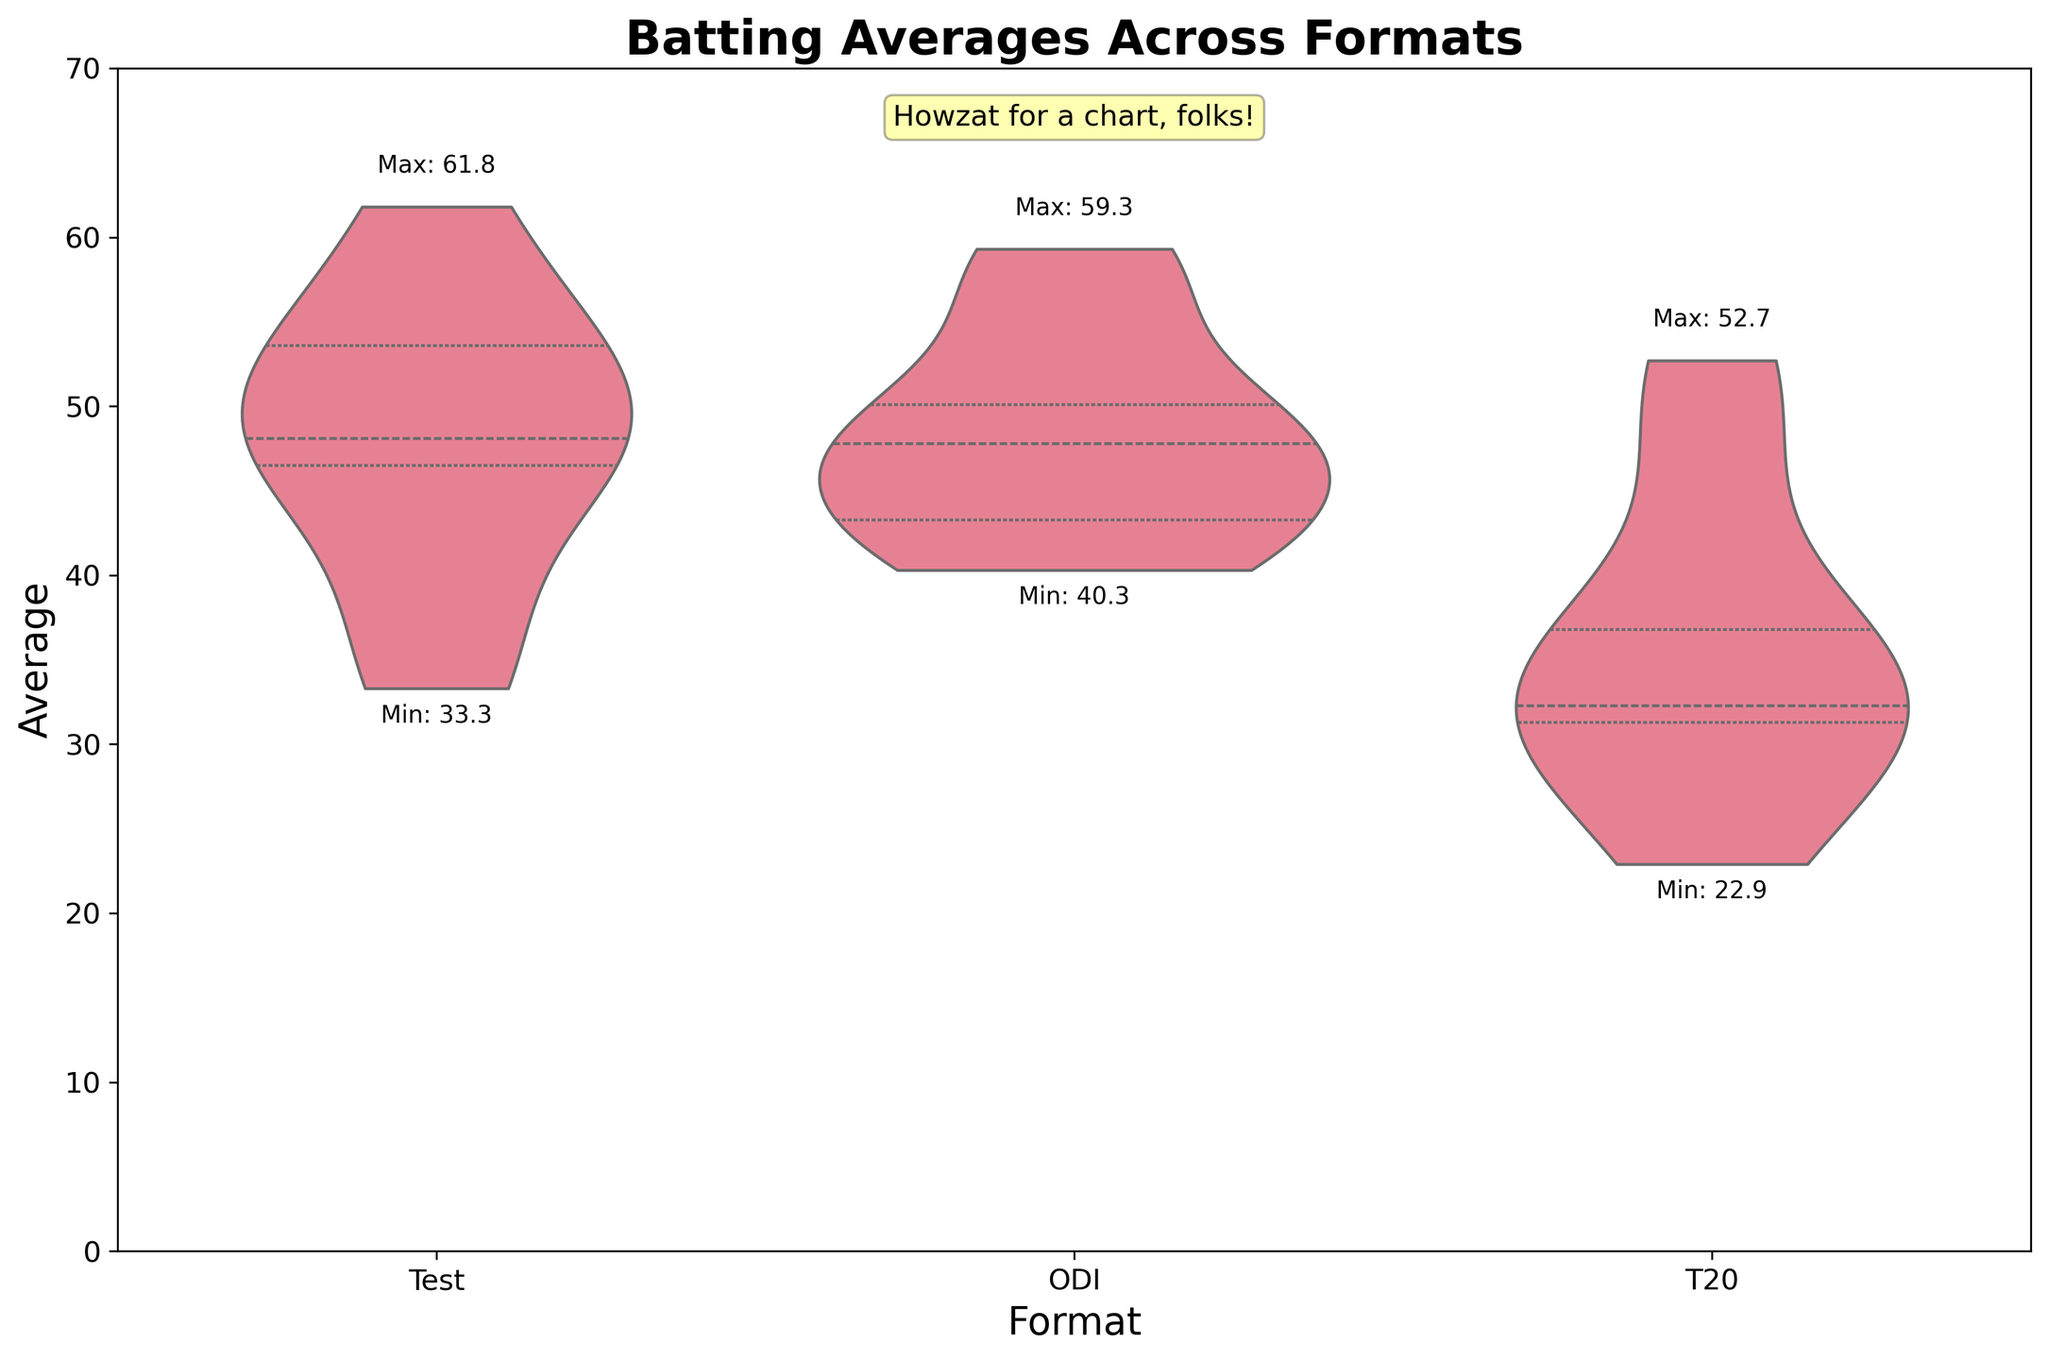What's the title of the plot? The title is typically located at the top of the plot. In this case, it reads "Batting Averages Across Formats".
Answer: Batting Averages Across Formats What is the maximum batting average in the Test format? The maximum value detailed above the respective violin plot for Test format. From the given information, it is shown as "Max: 61.8".
Answer: 61.8 How does the average in T20 format compare to Test and ODI formats overall? The violin plots show the distribution of batting averages for each format. Generally, it is possible to see that T20 averages are lower compared to Test and overall ODI averages by looking at the central clustering of values.
Answer: Lower Which format has the lowest reported batting average, and what is it? By reading the minimum value labels above each format in the plot, T20 has the lowest batting average labeled as "Min: 22.9".
Answer: T20, 22.9 Between Test and ODI formats, which one has a higher variance in batting averages? In a violin plot, the width of the plot at different values indicates the density. A wider plot hints at higher variance. The Test format's plot generally looks wider and more spread out compared to the ODI format.
Answer: Test Which player's average is annotated the highest for ODI format? By observing the plot and reading above the violin for ODI, "Max: 59.3" for Virat Kohli stands out based on the dataset.
Answer: Virat Kohli What is the range of batting averages in the T20 format? Range is calculated by subtracting the minimum value from the maximum value. From the annotations above T20, the range is "Max: 52.7" minus "Min: 22.9", which equals 29.8.
Answer: 29.8 If you were to compare Babar Azam and Ben Stokes, who performs better in ODI and by how much? From the dataset and plot, Babar Azam's average for ODI is 56.8, and Ben Stokes' average is 40.3. The difference is 56.8 - 40.3 = 16.5.
Answer: Babar Azam by 16.5 